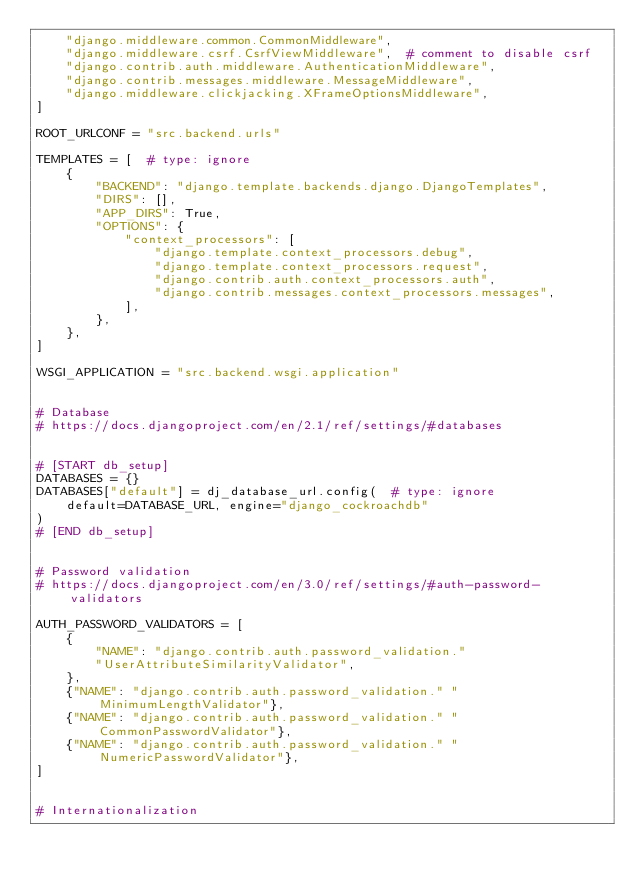<code> <loc_0><loc_0><loc_500><loc_500><_Python_>    "django.middleware.common.CommonMiddleware",
    "django.middleware.csrf.CsrfViewMiddleware",  # comment to disable csrf
    "django.contrib.auth.middleware.AuthenticationMiddleware",
    "django.contrib.messages.middleware.MessageMiddleware",
    "django.middleware.clickjacking.XFrameOptionsMiddleware",
]

ROOT_URLCONF = "src.backend.urls"

TEMPLATES = [  # type: ignore
    {
        "BACKEND": "django.template.backends.django.DjangoTemplates",
        "DIRS": [],
        "APP_DIRS": True,
        "OPTIONS": {
            "context_processors": [
                "django.template.context_processors.debug",
                "django.template.context_processors.request",
                "django.contrib.auth.context_processors.auth",
                "django.contrib.messages.context_processors.messages",
            ],
        },
    },
]

WSGI_APPLICATION = "src.backend.wsgi.application"


# Database
# https://docs.djangoproject.com/en/2.1/ref/settings/#databases


# [START db_setup]
DATABASES = {}
DATABASES["default"] = dj_database_url.config(  # type: ignore
    default=DATABASE_URL, engine="django_cockroachdb"
)
# [END db_setup]


# Password validation
# https://docs.djangoproject.com/en/3.0/ref/settings/#auth-password-validators

AUTH_PASSWORD_VALIDATORS = [
    {
        "NAME": "django.contrib.auth.password_validation."
        "UserAttributeSimilarityValidator",
    },
    {"NAME": "django.contrib.auth.password_validation." "MinimumLengthValidator"},
    {"NAME": "django.contrib.auth.password_validation." "CommonPasswordValidator"},
    {"NAME": "django.contrib.auth.password_validation." "NumericPasswordValidator"},
]


# Internationalization</code> 